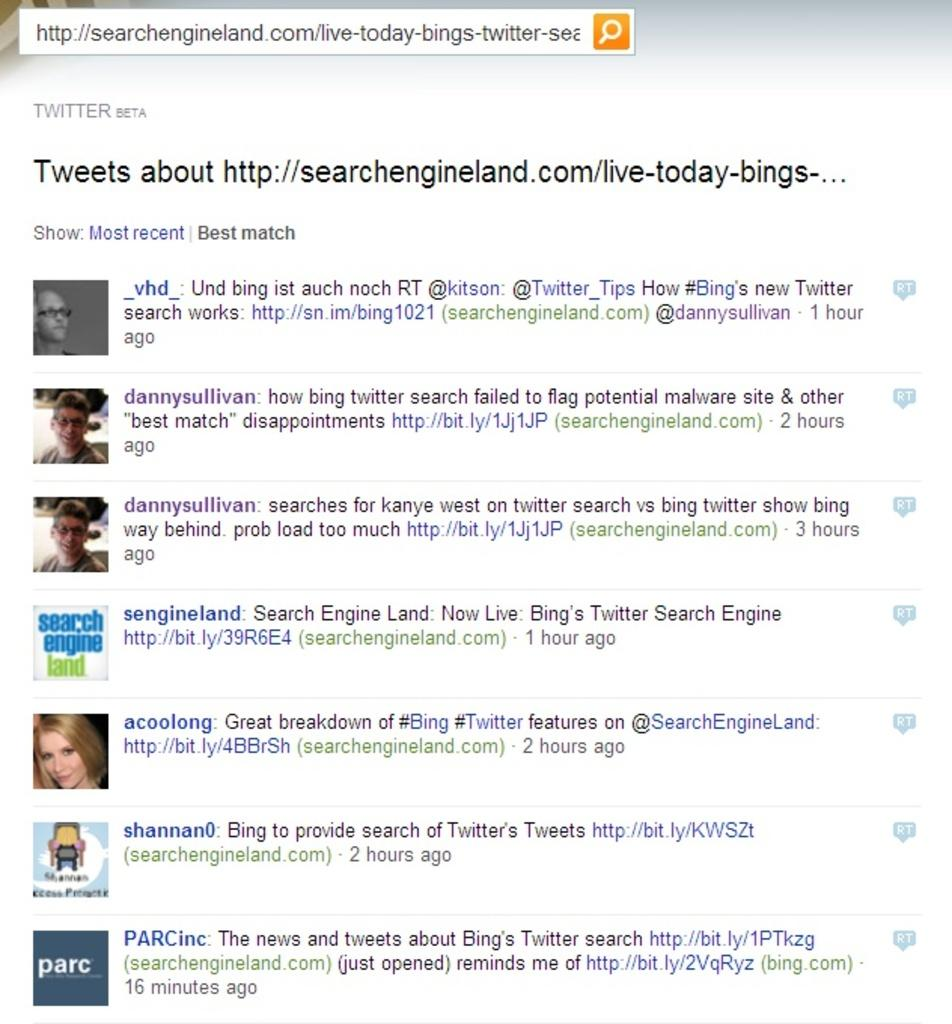What type of content is displayed in the image? The image contains a screenshot of tweets. How many tweets can be seen in the image? There are multiple tweets visible in the image. What type of cream is being used in the church depicted in the image? There is no cream or church present in the image; it only contains a screenshot of tweets. 